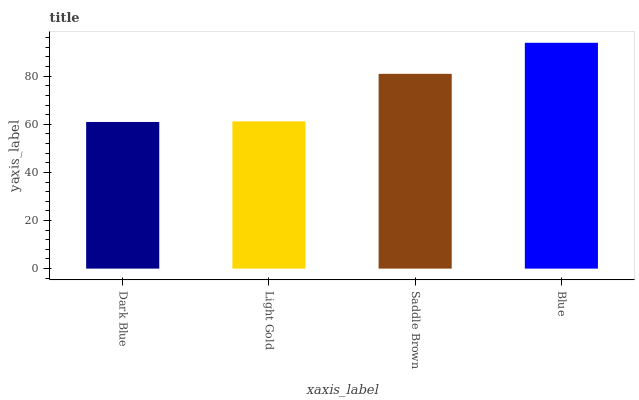Is Dark Blue the minimum?
Answer yes or no. Yes. Is Blue the maximum?
Answer yes or no. Yes. Is Light Gold the minimum?
Answer yes or no. No. Is Light Gold the maximum?
Answer yes or no. No. Is Light Gold greater than Dark Blue?
Answer yes or no. Yes. Is Dark Blue less than Light Gold?
Answer yes or no. Yes. Is Dark Blue greater than Light Gold?
Answer yes or no. No. Is Light Gold less than Dark Blue?
Answer yes or no. No. Is Saddle Brown the high median?
Answer yes or no. Yes. Is Light Gold the low median?
Answer yes or no. Yes. Is Blue the high median?
Answer yes or no. No. Is Dark Blue the low median?
Answer yes or no. No. 